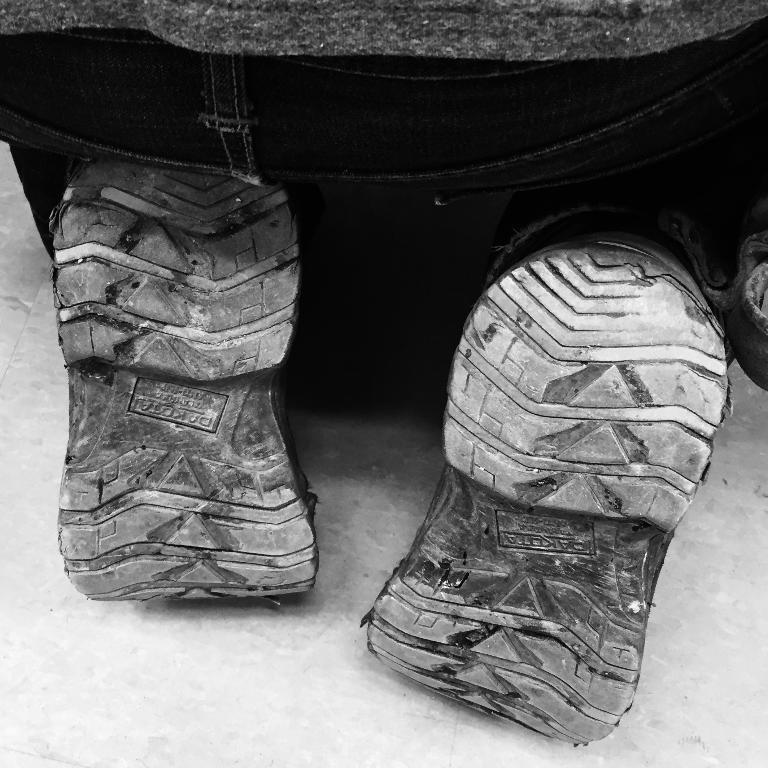What is the main subject of the image? There is a person in the image. What objects are in front of the person? There are two shoes in front of the person. What color scheme is used in the image? The image is in black and white. What type of shirt is the person wearing in the image? The image is in black and white, so it is not possible to determine the type of shirt the person is wearing. Additionally, there is no mention of a shirt in the provided facts. 